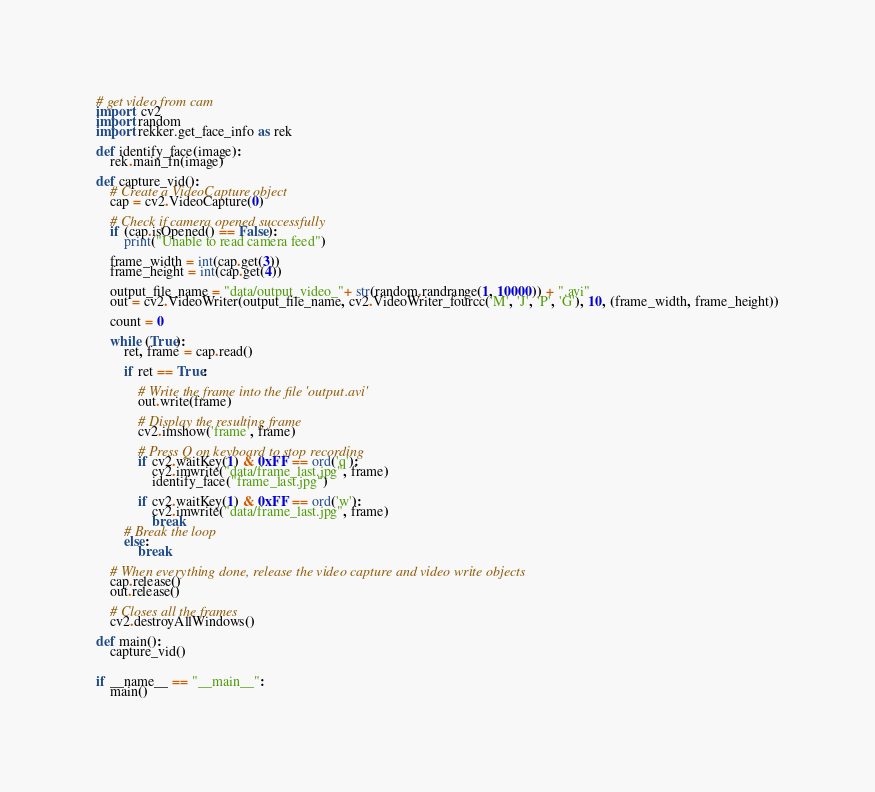<code> <loc_0><loc_0><loc_500><loc_500><_Python_># get video from cam
import  cv2
import random
import rekker.get_face_info as rek

def identify_face(image):
    rek.main_fn(image)

def capture_vid():
    # Create a VideoCapture object
    cap = cv2.VideoCapture(0)

    # Check if camera opened successfully
    if (cap.isOpened() == False):
        print("Unable to read camera feed")

    frame_width = int(cap.get(3))
    frame_height = int(cap.get(4))

    output_file_name = "data/output_video_"+ str(random.randrange(1, 10000)) + ".avi"
    out = cv2.VideoWriter(output_file_name, cv2.VideoWriter_fourcc('M', 'J', 'P', 'G'), 10, (frame_width, frame_height))

    count = 0

    while (True):
        ret, frame = cap.read()

        if ret == True:

            # Write the frame into the file 'output.avi'
            out.write(frame)

            # Display the resulting frame
            cv2.imshow('frame', frame)

            # Press Q on keyboard to stop recording
            if cv2.waitKey(1) & 0xFF == ord('q'):
                cv2.imwrite("data/frame_last.jpg", frame)
                identify_face("frame_last.jpg")

            if cv2.waitKey(1) & 0xFF == ord('w'):
                cv2.imwrite("data/frame_last.jpg", frame)
                break
        # Break the loop
        else:
            break

    # When everything done, release the video capture and video write objects
    cap.release()
    out.release()

    # Closes all the frames
    cv2.destroyAllWindows()

def main():
    capture_vid()


if __name__ == "__main__":
    main()</code> 